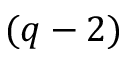Convert formula to latex. <formula><loc_0><loc_0><loc_500><loc_500>( q - 2 )</formula> 